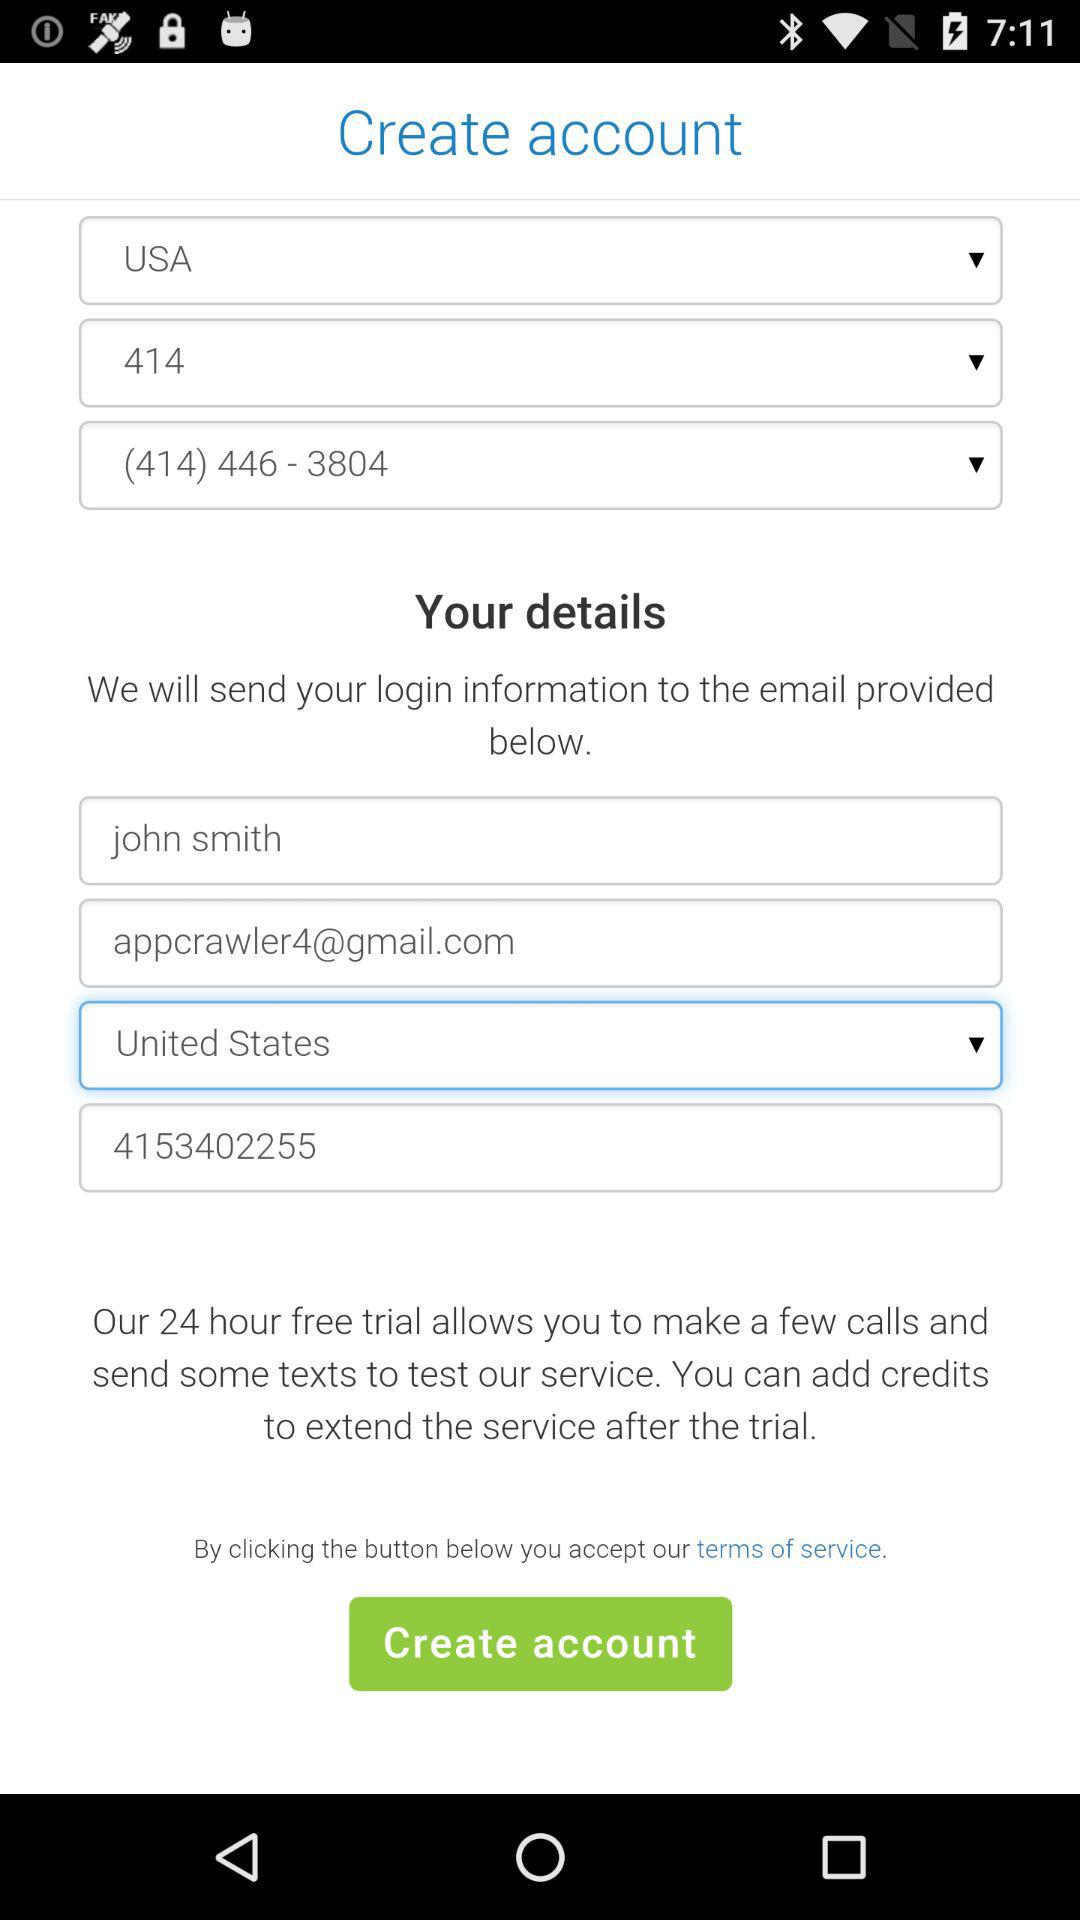What is the selected country? The selected country is the United States. 